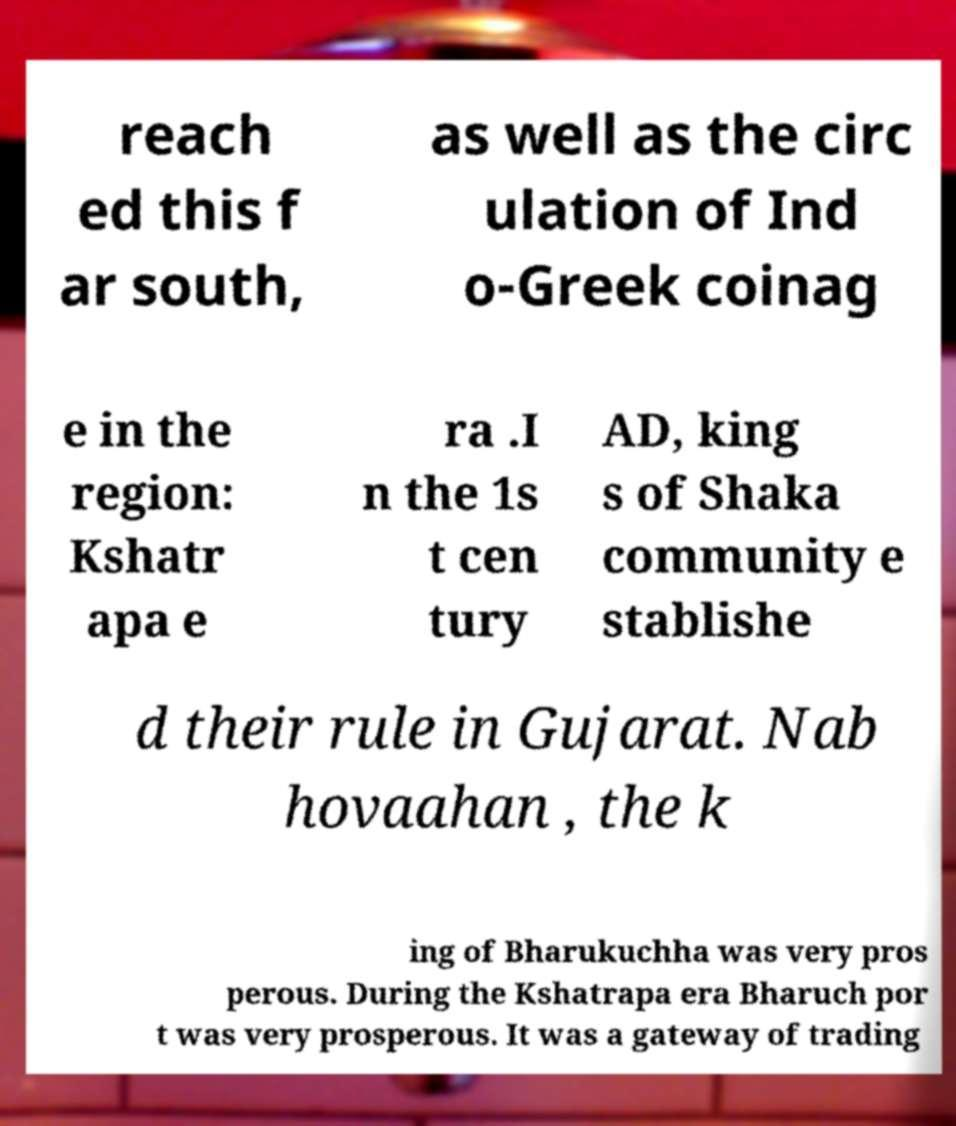Could you assist in decoding the text presented in this image and type it out clearly? reach ed this f ar south, as well as the circ ulation of Ind o-Greek coinag e in the region: Kshatr apa e ra .I n the 1s t cen tury AD, king s of Shaka community e stablishe d their rule in Gujarat. Nab hovaahan , the k ing of Bharukuchha was very pros perous. During the Kshatrapa era Bharuch por t was very prosperous. It was a gateway of trading 